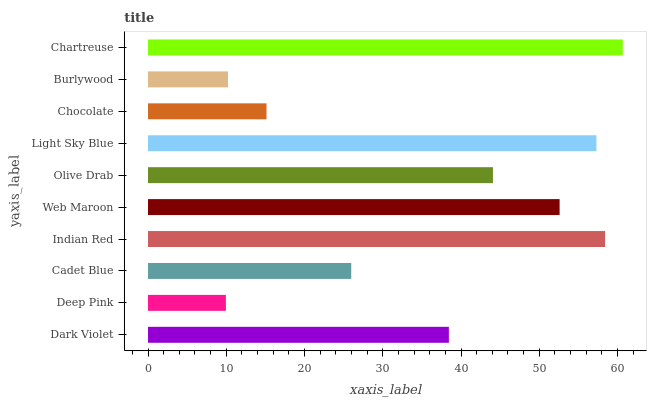Is Deep Pink the minimum?
Answer yes or no. Yes. Is Chartreuse the maximum?
Answer yes or no. Yes. Is Cadet Blue the minimum?
Answer yes or no. No. Is Cadet Blue the maximum?
Answer yes or no. No. Is Cadet Blue greater than Deep Pink?
Answer yes or no. Yes. Is Deep Pink less than Cadet Blue?
Answer yes or no. Yes. Is Deep Pink greater than Cadet Blue?
Answer yes or no. No. Is Cadet Blue less than Deep Pink?
Answer yes or no. No. Is Olive Drab the high median?
Answer yes or no. Yes. Is Dark Violet the low median?
Answer yes or no. Yes. Is Web Maroon the high median?
Answer yes or no. No. Is Chocolate the low median?
Answer yes or no. No. 